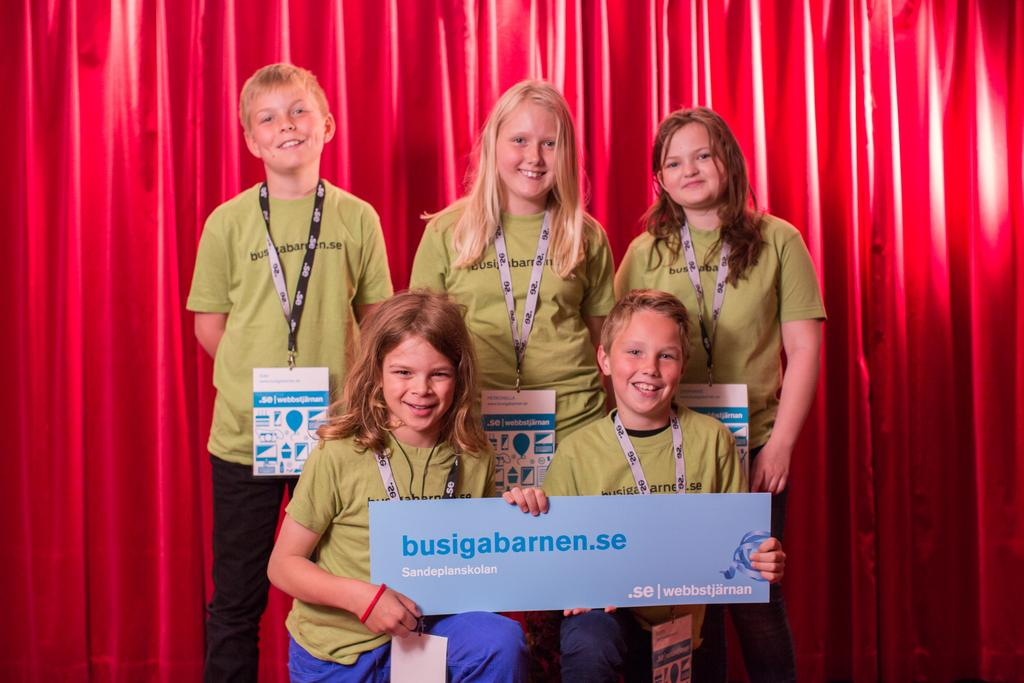What can be seen in the image? There is a group of children in the image. What are the children wearing? The children are wearing ID cards. What are the boy and girl holding? They are holding a board with text. What can be seen at the top of the image? There are curtains visible at the top of the image. How many centimeters is the moon visible in the image? There is no moon visible in the image. What color is the sock on the boy's foot in the image? There is no sock visible on the boy's foot in the image. 